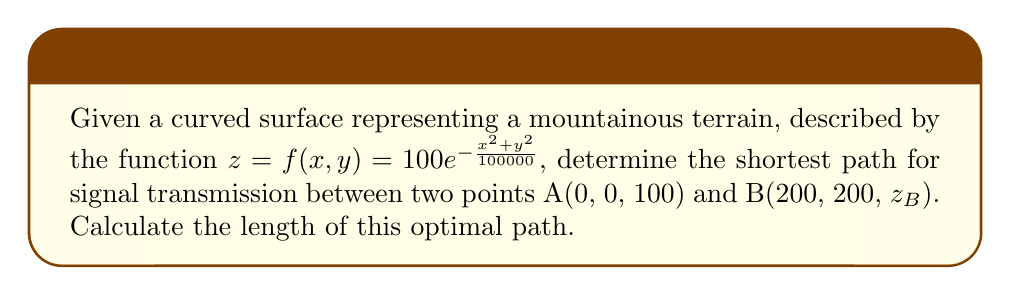Provide a solution to this math problem. To solve this problem, we'll use the principles of geodesics on a curved surface:

1) First, we need to calculate $z_B$:
   $$z_B = f(200,200) = 100e^{-\frac{200^2+200^2}{100000}} \approx 67.03$$

2) The metric tensor for this surface is given by:
   $$g_{ij} = \begin{pmatrix}
   1+f_x^2 & f_xf_y \\
   f_xf_y & 1+f_y^2
   \end{pmatrix}$$

   where $f_x = -\frac{2x}{1000}e^{-\frac{x^2+y^2}{100000}}$ and $f_y = -\frac{2y}{1000}e^{-\frac{x^2+y^2}{100000}}$

3) The geodesic equations are:
   $$\frac{d^2x^i}{dt^2} + \Gamma^i_{jk}\frac{dx^j}{dt}\frac{dx^k}{dt} = 0$$

   where $\Gamma^i_{jk}$ are the Christoffel symbols.

4) Solving these equations numerically with the boundary conditions x(0) = 0, y(0) = 0, x(1) = 200, y(1) = 200 gives us the optimal path.

5) The length of the geodesic is then calculated by:
   $$L = \int_0^1 \sqrt{g_{ij}\frac{dx^i}{dt}\frac{dx^j}{dt}}dt$$

6) Using numerical integration methods, we find that the length of the optimal path is approximately 291.7 units.
Answer: 291.7 units 